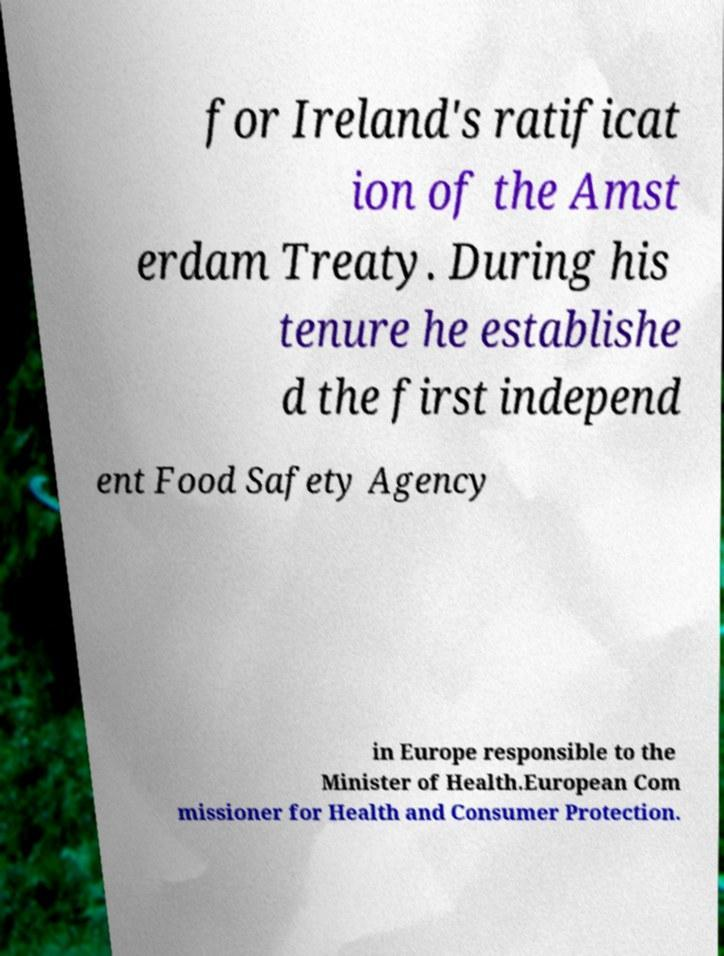For documentation purposes, I need the text within this image transcribed. Could you provide that? for Ireland's ratificat ion of the Amst erdam Treaty. During his tenure he establishe d the first independ ent Food Safety Agency in Europe responsible to the Minister of Health.European Com missioner for Health and Consumer Protection. 